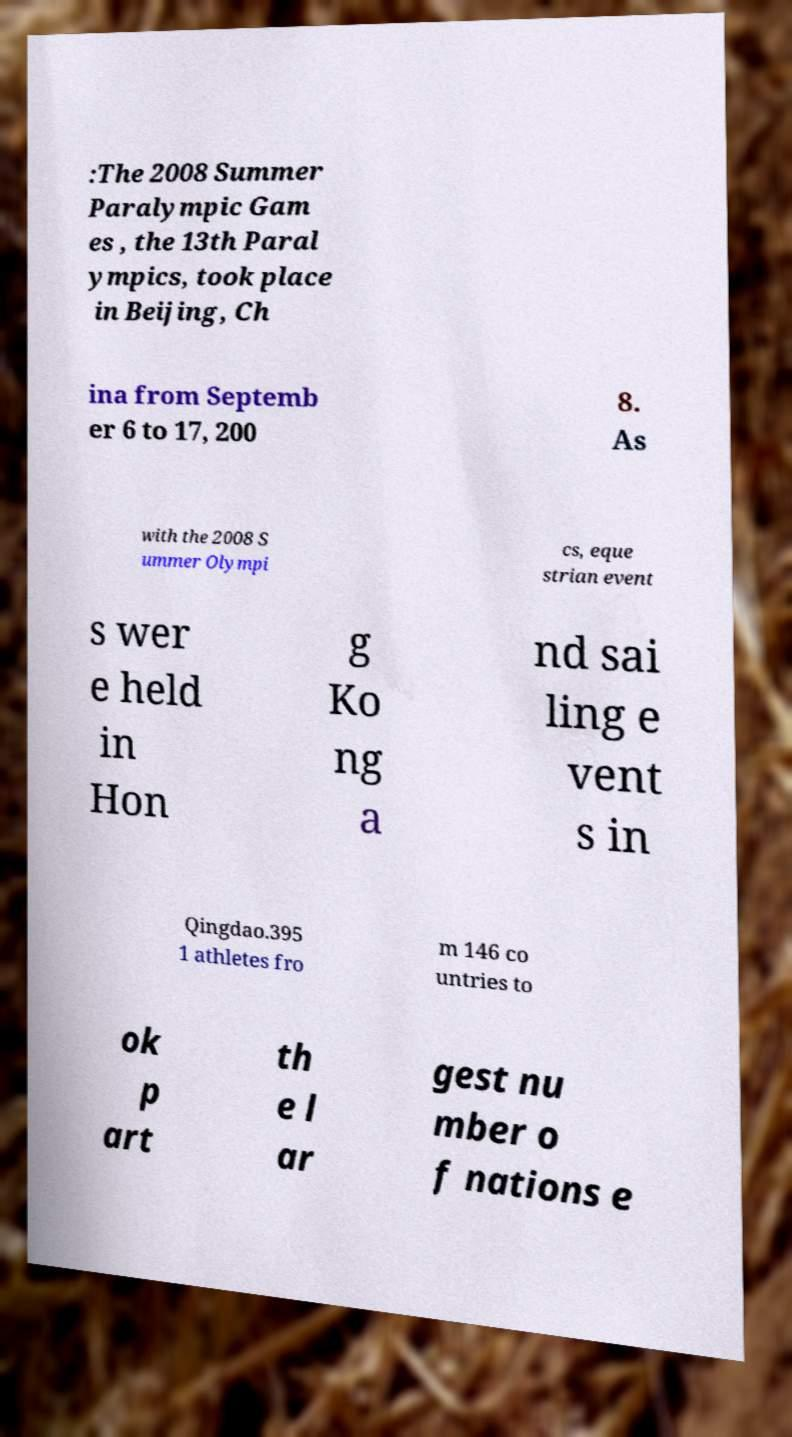Can you read and provide the text displayed in the image?This photo seems to have some interesting text. Can you extract and type it out for me? :The 2008 Summer Paralympic Gam es , the 13th Paral ympics, took place in Beijing, Ch ina from Septemb er 6 to 17, 200 8. As with the 2008 S ummer Olympi cs, eque strian event s wer e held in Hon g Ko ng a nd sai ling e vent s in Qingdao.395 1 athletes fro m 146 co untries to ok p art th e l ar gest nu mber o f nations e 